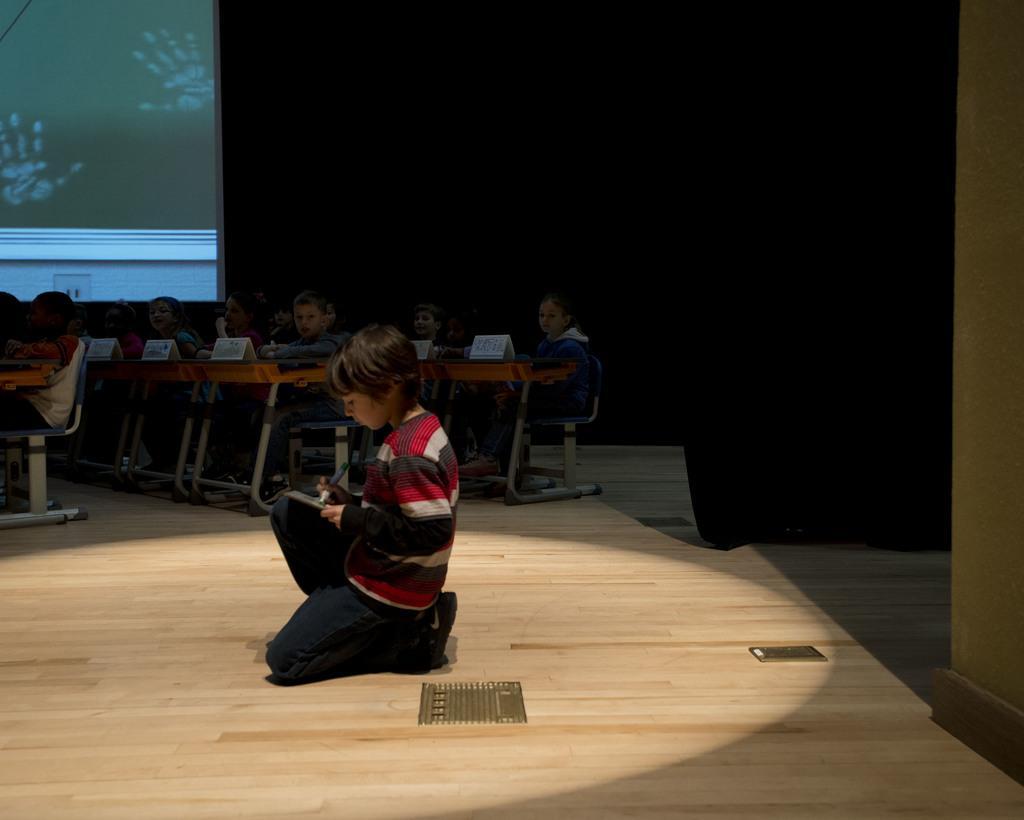In one or two sentences, can you explain what this image depicts? In this image I can see children sitting on chairs. In the background I can see a wall and other objects. 